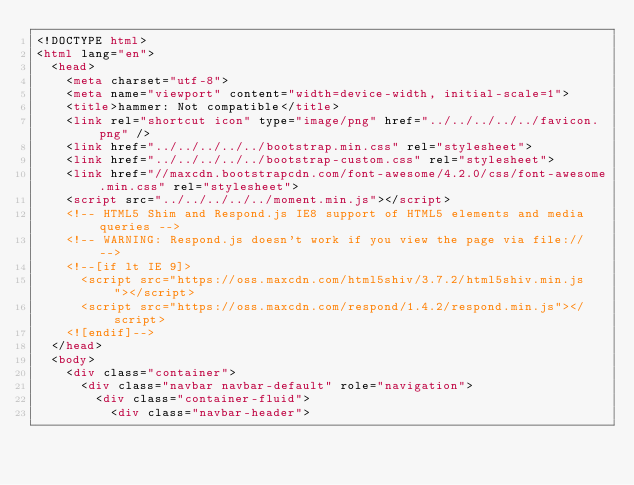<code> <loc_0><loc_0><loc_500><loc_500><_HTML_><!DOCTYPE html>
<html lang="en">
  <head>
    <meta charset="utf-8">
    <meta name="viewport" content="width=device-width, initial-scale=1">
    <title>hammer: Not compatible</title>
    <link rel="shortcut icon" type="image/png" href="../../../../../favicon.png" />
    <link href="../../../../../bootstrap.min.css" rel="stylesheet">
    <link href="../../../../../bootstrap-custom.css" rel="stylesheet">
    <link href="//maxcdn.bootstrapcdn.com/font-awesome/4.2.0/css/font-awesome.min.css" rel="stylesheet">
    <script src="../../../../../moment.min.js"></script>
    <!-- HTML5 Shim and Respond.js IE8 support of HTML5 elements and media queries -->
    <!-- WARNING: Respond.js doesn't work if you view the page via file:// -->
    <!--[if lt IE 9]>
      <script src="https://oss.maxcdn.com/html5shiv/3.7.2/html5shiv.min.js"></script>
      <script src="https://oss.maxcdn.com/respond/1.4.2/respond.min.js"></script>
    <![endif]-->
  </head>
  <body>
    <div class="container">
      <div class="navbar navbar-default" role="navigation">
        <div class="container-fluid">
          <div class="navbar-header"></code> 